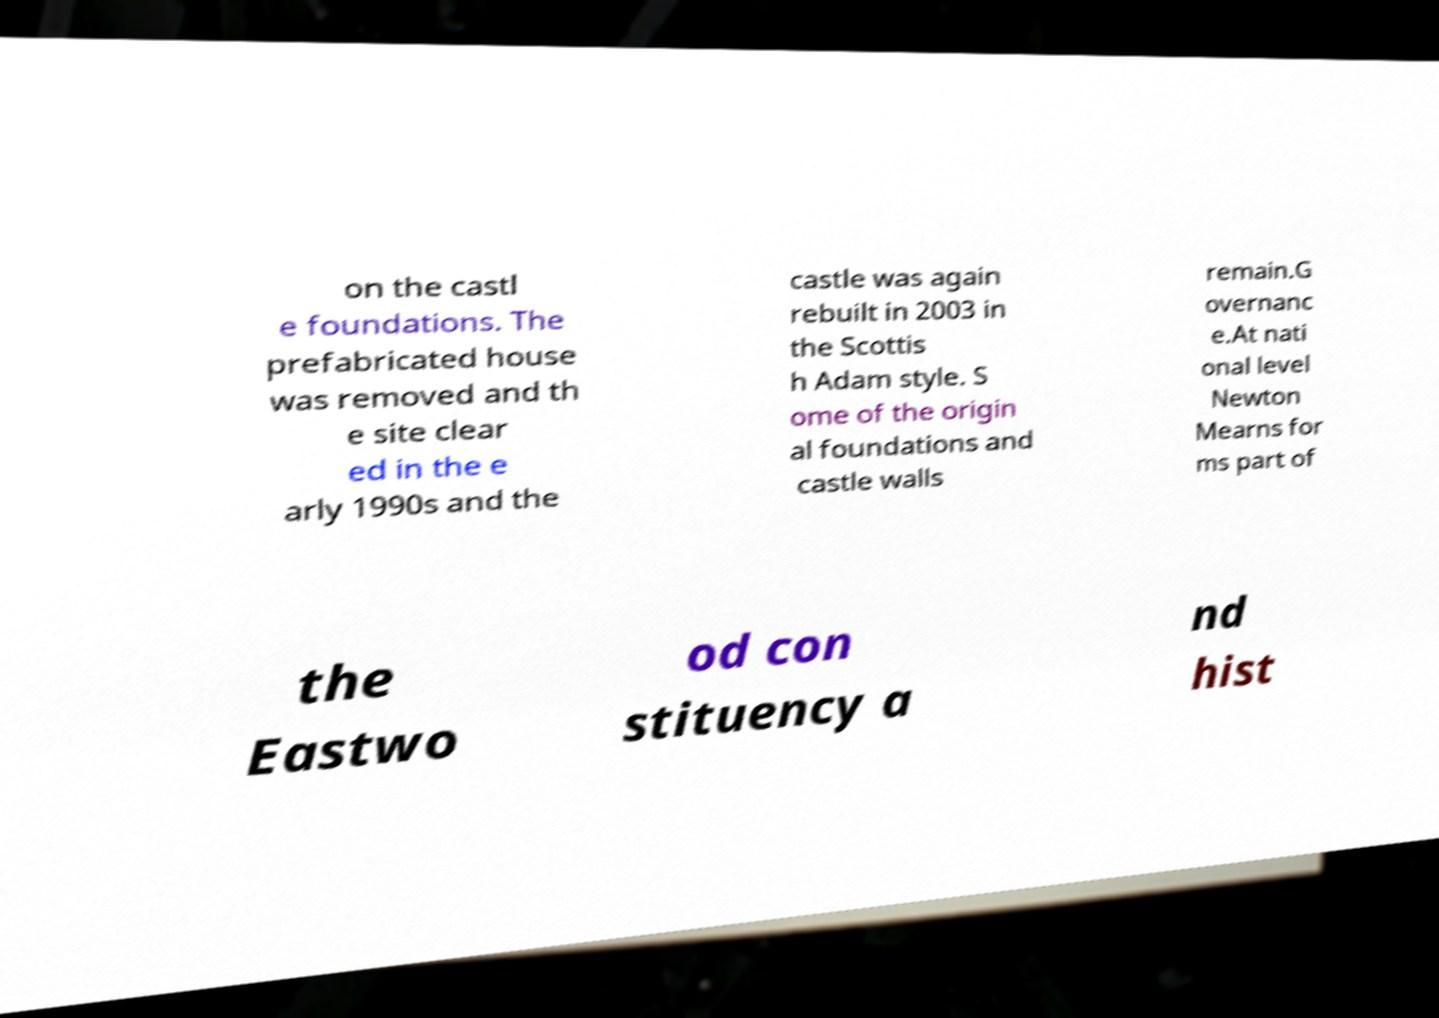What messages or text are displayed in this image? I need them in a readable, typed format. on the castl e foundations. The prefabricated house was removed and th e site clear ed in the e arly 1990s and the castle was again rebuilt in 2003 in the Scottis h Adam style. S ome of the origin al foundations and castle walls remain.G overnanc e.At nati onal level Newton Mearns for ms part of the Eastwo od con stituency a nd hist 